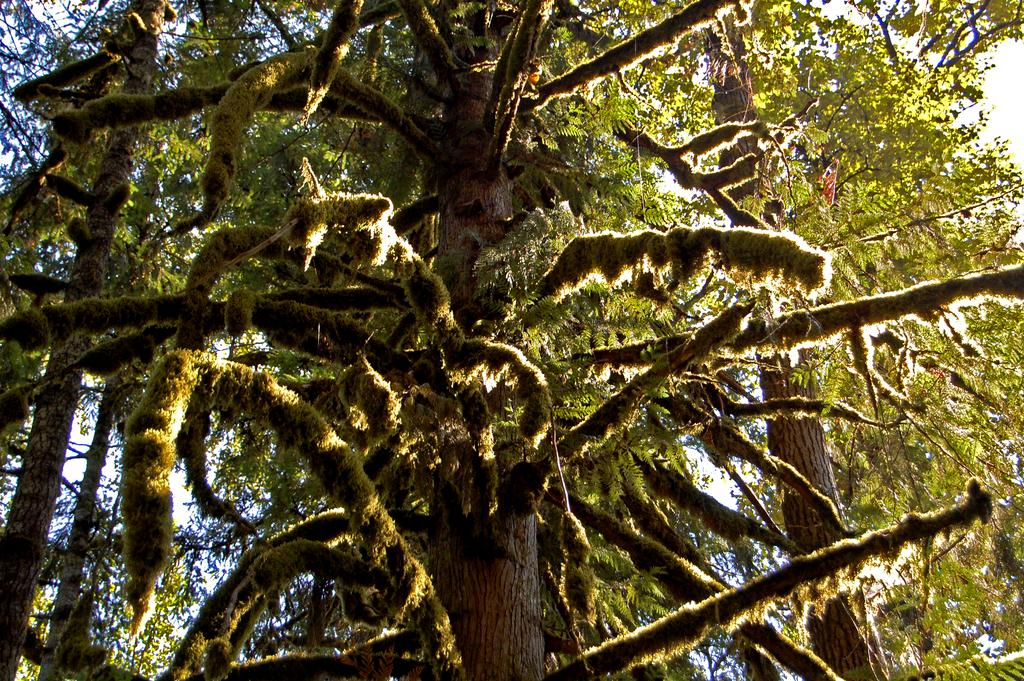What type of vegetation can be seen in the image? There are trees in the image. What part of the natural environment is visible in the image? The sky is visible in the background of the image. How many arms are visible on the trees in the image? Trees do not have arms; they have branches. The image does not show any visible branches that could be mistaken for arms. 